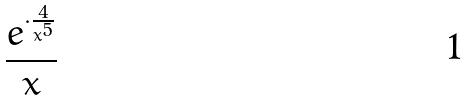<formula> <loc_0><loc_0><loc_500><loc_500>\frac { e ^ { \cdot \frac { 4 } { x ^ { 5 } } } } { x }</formula> 